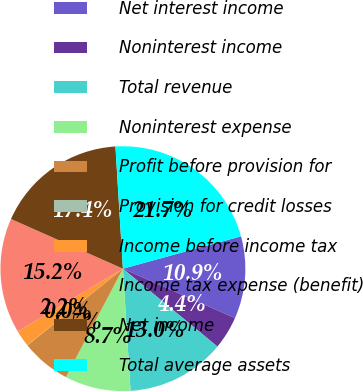Convert chart to OTSL. <chart><loc_0><loc_0><loc_500><loc_500><pie_chart><fcel>Net interest income<fcel>Noninterest income<fcel>Total revenue<fcel>Noninterest expense<fcel>Profit before provision for<fcel>Provision for credit losses<fcel>Income before income tax<fcel>Income tax expense (benefit)<fcel>Net income<fcel>Total average assets<nl><fcel>10.87%<fcel>4.36%<fcel>13.04%<fcel>8.7%<fcel>6.53%<fcel>0.02%<fcel>2.19%<fcel>15.21%<fcel>17.38%<fcel>21.72%<nl></chart> 